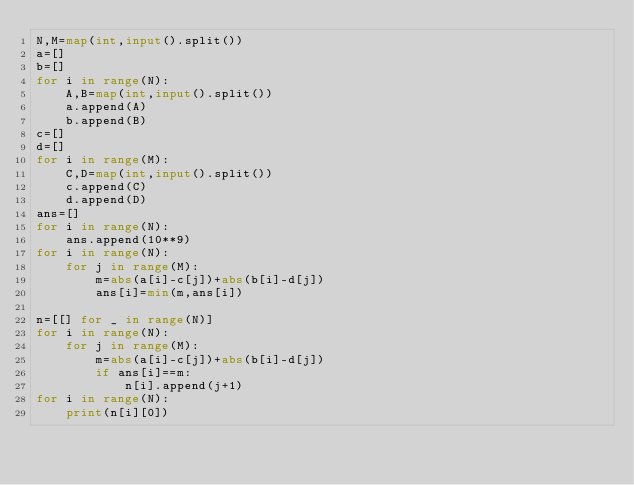Convert code to text. <code><loc_0><loc_0><loc_500><loc_500><_Python_>N,M=map(int,input().split())
a=[]
b=[]
for i in range(N):
    A,B=map(int,input().split())
    a.append(A)
    b.append(B)
c=[]
d=[]
for i in range(M):
    C,D=map(int,input().split())
    c.append(C)
    d.append(D)
ans=[]
for i in range(N):
    ans.append(10**9)
for i in range(N):
    for j in range(M):
        m=abs(a[i]-c[j])+abs(b[i]-d[j])
        ans[i]=min(m,ans[i])

n=[[] for _ in range(N)]
for i in range(N):
    for j in range(M):
        m=abs(a[i]-c[j])+abs(b[i]-d[j])
        if ans[i]==m:
            n[i].append(j+1)
for i in range(N):
    print(n[i][0])</code> 